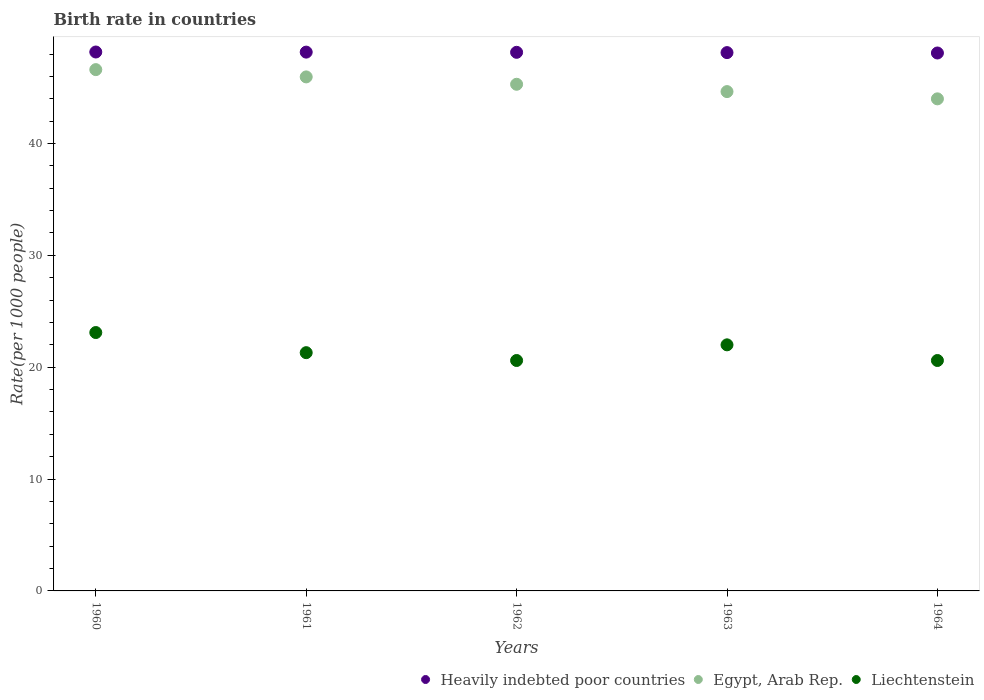What is the birth rate in Egypt, Arab Rep. in 1961?
Provide a short and direct response. 45.95. Across all years, what is the maximum birth rate in Heavily indebted poor countries?
Your response must be concise. 48.18. Across all years, what is the minimum birth rate in Egypt, Arab Rep.?
Offer a terse response. 43.99. In which year was the birth rate in Liechtenstein maximum?
Provide a succinct answer. 1960. What is the total birth rate in Heavily indebted poor countries in the graph?
Offer a very short reply. 240.72. What is the difference between the birth rate in Egypt, Arab Rep. in 1961 and that in 1962?
Provide a short and direct response. 0.66. What is the difference between the birth rate in Liechtenstein in 1962 and the birth rate in Egypt, Arab Rep. in 1963?
Offer a terse response. -24.04. What is the average birth rate in Liechtenstein per year?
Offer a terse response. 21.52. In the year 1964, what is the difference between the birth rate in Liechtenstein and birth rate in Egypt, Arab Rep.?
Give a very brief answer. -23.39. What is the ratio of the birth rate in Liechtenstein in 1961 to that in 1964?
Your response must be concise. 1.03. Is the birth rate in Egypt, Arab Rep. in 1960 less than that in 1963?
Your response must be concise. No. What is the difference between the highest and the second highest birth rate in Heavily indebted poor countries?
Offer a very short reply. 0.01. What is the difference between the highest and the lowest birth rate in Liechtenstein?
Keep it short and to the point. 2.5. In how many years, is the birth rate in Heavily indebted poor countries greater than the average birth rate in Heavily indebted poor countries taken over all years?
Your response must be concise. 3. Is the birth rate in Egypt, Arab Rep. strictly greater than the birth rate in Heavily indebted poor countries over the years?
Keep it short and to the point. No. How many dotlines are there?
Give a very brief answer. 3. How many years are there in the graph?
Provide a short and direct response. 5. Are the values on the major ticks of Y-axis written in scientific E-notation?
Provide a succinct answer. No. Does the graph contain grids?
Your answer should be compact. No. How are the legend labels stacked?
Make the answer very short. Horizontal. What is the title of the graph?
Your answer should be very brief. Birth rate in countries. What is the label or title of the Y-axis?
Your response must be concise. Rate(per 1000 people). What is the Rate(per 1000 people) in Heavily indebted poor countries in 1960?
Provide a succinct answer. 48.18. What is the Rate(per 1000 people) in Egypt, Arab Rep. in 1960?
Your answer should be very brief. 46.6. What is the Rate(per 1000 people) of Liechtenstein in 1960?
Your answer should be compact. 23.1. What is the Rate(per 1000 people) of Heavily indebted poor countries in 1961?
Your answer should be very brief. 48.17. What is the Rate(per 1000 people) of Egypt, Arab Rep. in 1961?
Your answer should be compact. 45.95. What is the Rate(per 1000 people) of Liechtenstein in 1961?
Offer a terse response. 21.3. What is the Rate(per 1000 people) of Heavily indebted poor countries in 1962?
Your answer should be very brief. 48.15. What is the Rate(per 1000 people) of Egypt, Arab Rep. in 1962?
Keep it short and to the point. 45.3. What is the Rate(per 1000 people) in Liechtenstein in 1962?
Your answer should be compact. 20.6. What is the Rate(per 1000 people) of Heavily indebted poor countries in 1963?
Give a very brief answer. 48.13. What is the Rate(per 1000 people) in Egypt, Arab Rep. in 1963?
Offer a terse response. 44.64. What is the Rate(per 1000 people) of Liechtenstein in 1963?
Your answer should be very brief. 22. What is the Rate(per 1000 people) of Heavily indebted poor countries in 1964?
Give a very brief answer. 48.09. What is the Rate(per 1000 people) in Egypt, Arab Rep. in 1964?
Your answer should be compact. 43.99. What is the Rate(per 1000 people) of Liechtenstein in 1964?
Offer a very short reply. 20.6. Across all years, what is the maximum Rate(per 1000 people) of Heavily indebted poor countries?
Offer a very short reply. 48.18. Across all years, what is the maximum Rate(per 1000 people) of Egypt, Arab Rep.?
Give a very brief answer. 46.6. Across all years, what is the maximum Rate(per 1000 people) of Liechtenstein?
Keep it short and to the point. 23.1. Across all years, what is the minimum Rate(per 1000 people) of Heavily indebted poor countries?
Give a very brief answer. 48.09. Across all years, what is the minimum Rate(per 1000 people) of Egypt, Arab Rep.?
Offer a terse response. 43.99. Across all years, what is the minimum Rate(per 1000 people) in Liechtenstein?
Ensure brevity in your answer.  20.6. What is the total Rate(per 1000 people) of Heavily indebted poor countries in the graph?
Provide a short and direct response. 240.72. What is the total Rate(per 1000 people) of Egypt, Arab Rep. in the graph?
Make the answer very short. 226.49. What is the total Rate(per 1000 people) of Liechtenstein in the graph?
Ensure brevity in your answer.  107.6. What is the difference between the Rate(per 1000 people) of Heavily indebted poor countries in 1960 and that in 1961?
Give a very brief answer. 0.01. What is the difference between the Rate(per 1000 people) of Egypt, Arab Rep. in 1960 and that in 1961?
Your response must be concise. 0.65. What is the difference between the Rate(per 1000 people) in Heavily indebted poor countries in 1960 and that in 1962?
Offer a terse response. 0.03. What is the difference between the Rate(per 1000 people) of Egypt, Arab Rep. in 1960 and that in 1962?
Ensure brevity in your answer.  1.31. What is the difference between the Rate(per 1000 people) in Liechtenstein in 1960 and that in 1962?
Offer a very short reply. 2.5. What is the difference between the Rate(per 1000 people) of Heavily indebted poor countries in 1960 and that in 1963?
Your answer should be compact. 0.05. What is the difference between the Rate(per 1000 people) of Egypt, Arab Rep. in 1960 and that in 1963?
Offer a terse response. 1.97. What is the difference between the Rate(per 1000 people) in Liechtenstein in 1960 and that in 1963?
Your response must be concise. 1.1. What is the difference between the Rate(per 1000 people) in Heavily indebted poor countries in 1960 and that in 1964?
Provide a short and direct response. 0.09. What is the difference between the Rate(per 1000 people) in Egypt, Arab Rep. in 1960 and that in 1964?
Offer a very short reply. 2.61. What is the difference between the Rate(per 1000 people) of Heavily indebted poor countries in 1961 and that in 1962?
Keep it short and to the point. 0.02. What is the difference between the Rate(per 1000 people) in Egypt, Arab Rep. in 1961 and that in 1962?
Provide a short and direct response. 0.66. What is the difference between the Rate(per 1000 people) in Heavily indebted poor countries in 1961 and that in 1963?
Keep it short and to the point. 0.04. What is the difference between the Rate(per 1000 people) of Egypt, Arab Rep. in 1961 and that in 1963?
Keep it short and to the point. 1.31. What is the difference between the Rate(per 1000 people) of Heavily indebted poor countries in 1961 and that in 1964?
Give a very brief answer. 0.08. What is the difference between the Rate(per 1000 people) of Egypt, Arab Rep. in 1961 and that in 1964?
Offer a terse response. 1.96. What is the difference between the Rate(per 1000 people) in Liechtenstein in 1961 and that in 1964?
Provide a short and direct response. 0.7. What is the difference between the Rate(per 1000 people) in Heavily indebted poor countries in 1962 and that in 1963?
Ensure brevity in your answer.  0.03. What is the difference between the Rate(per 1000 people) in Egypt, Arab Rep. in 1962 and that in 1963?
Make the answer very short. 0.66. What is the difference between the Rate(per 1000 people) in Heavily indebted poor countries in 1962 and that in 1964?
Keep it short and to the point. 0.06. What is the difference between the Rate(per 1000 people) in Egypt, Arab Rep. in 1962 and that in 1964?
Offer a terse response. 1.3. What is the difference between the Rate(per 1000 people) in Liechtenstein in 1962 and that in 1964?
Your response must be concise. 0. What is the difference between the Rate(per 1000 people) in Heavily indebted poor countries in 1963 and that in 1964?
Offer a very short reply. 0.03. What is the difference between the Rate(per 1000 people) in Egypt, Arab Rep. in 1963 and that in 1964?
Make the answer very short. 0.65. What is the difference between the Rate(per 1000 people) of Liechtenstein in 1963 and that in 1964?
Provide a succinct answer. 1.4. What is the difference between the Rate(per 1000 people) of Heavily indebted poor countries in 1960 and the Rate(per 1000 people) of Egypt, Arab Rep. in 1961?
Give a very brief answer. 2.23. What is the difference between the Rate(per 1000 people) of Heavily indebted poor countries in 1960 and the Rate(per 1000 people) of Liechtenstein in 1961?
Your answer should be very brief. 26.88. What is the difference between the Rate(per 1000 people) of Egypt, Arab Rep. in 1960 and the Rate(per 1000 people) of Liechtenstein in 1961?
Keep it short and to the point. 25.3. What is the difference between the Rate(per 1000 people) of Heavily indebted poor countries in 1960 and the Rate(per 1000 people) of Egypt, Arab Rep. in 1962?
Give a very brief answer. 2.88. What is the difference between the Rate(per 1000 people) in Heavily indebted poor countries in 1960 and the Rate(per 1000 people) in Liechtenstein in 1962?
Offer a very short reply. 27.58. What is the difference between the Rate(per 1000 people) in Egypt, Arab Rep. in 1960 and the Rate(per 1000 people) in Liechtenstein in 1962?
Provide a short and direct response. 26. What is the difference between the Rate(per 1000 people) of Heavily indebted poor countries in 1960 and the Rate(per 1000 people) of Egypt, Arab Rep. in 1963?
Provide a short and direct response. 3.54. What is the difference between the Rate(per 1000 people) in Heavily indebted poor countries in 1960 and the Rate(per 1000 people) in Liechtenstein in 1963?
Offer a very short reply. 26.18. What is the difference between the Rate(per 1000 people) in Egypt, Arab Rep. in 1960 and the Rate(per 1000 people) in Liechtenstein in 1963?
Offer a terse response. 24.61. What is the difference between the Rate(per 1000 people) of Heavily indebted poor countries in 1960 and the Rate(per 1000 people) of Egypt, Arab Rep. in 1964?
Your response must be concise. 4.19. What is the difference between the Rate(per 1000 people) of Heavily indebted poor countries in 1960 and the Rate(per 1000 people) of Liechtenstein in 1964?
Provide a short and direct response. 27.58. What is the difference between the Rate(per 1000 people) of Egypt, Arab Rep. in 1960 and the Rate(per 1000 people) of Liechtenstein in 1964?
Offer a terse response. 26. What is the difference between the Rate(per 1000 people) of Heavily indebted poor countries in 1961 and the Rate(per 1000 people) of Egypt, Arab Rep. in 1962?
Your answer should be compact. 2.87. What is the difference between the Rate(per 1000 people) in Heavily indebted poor countries in 1961 and the Rate(per 1000 people) in Liechtenstein in 1962?
Your response must be concise. 27.57. What is the difference between the Rate(per 1000 people) in Egypt, Arab Rep. in 1961 and the Rate(per 1000 people) in Liechtenstein in 1962?
Ensure brevity in your answer.  25.35. What is the difference between the Rate(per 1000 people) in Heavily indebted poor countries in 1961 and the Rate(per 1000 people) in Egypt, Arab Rep. in 1963?
Give a very brief answer. 3.53. What is the difference between the Rate(per 1000 people) in Heavily indebted poor countries in 1961 and the Rate(per 1000 people) in Liechtenstein in 1963?
Your answer should be compact. 26.17. What is the difference between the Rate(per 1000 people) of Egypt, Arab Rep. in 1961 and the Rate(per 1000 people) of Liechtenstein in 1963?
Offer a very short reply. 23.95. What is the difference between the Rate(per 1000 people) of Heavily indebted poor countries in 1961 and the Rate(per 1000 people) of Egypt, Arab Rep. in 1964?
Your answer should be very brief. 4.18. What is the difference between the Rate(per 1000 people) in Heavily indebted poor countries in 1961 and the Rate(per 1000 people) in Liechtenstein in 1964?
Offer a very short reply. 27.57. What is the difference between the Rate(per 1000 people) in Egypt, Arab Rep. in 1961 and the Rate(per 1000 people) in Liechtenstein in 1964?
Provide a short and direct response. 25.35. What is the difference between the Rate(per 1000 people) of Heavily indebted poor countries in 1962 and the Rate(per 1000 people) of Egypt, Arab Rep. in 1963?
Make the answer very short. 3.51. What is the difference between the Rate(per 1000 people) of Heavily indebted poor countries in 1962 and the Rate(per 1000 people) of Liechtenstein in 1963?
Your answer should be very brief. 26.15. What is the difference between the Rate(per 1000 people) in Egypt, Arab Rep. in 1962 and the Rate(per 1000 people) in Liechtenstein in 1963?
Offer a very short reply. 23.3. What is the difference between the Rate(per 1000 people) of Heavily indebted poor countries in 1962 and the Rate(per 1000 people) of Egypt, Arab Rep. in 1964?
Offer a very short reply. 4.16. What is the difference between the Rate(per 1000 people) in Heavily indebted poor countries in 1962 and the Rate(per 1000 people) in Liechtenstein in 1964?
Your answer should be compact. 27.55. What is the difference between the Rate(per 1000 people) in Egypt, Arab Rep. in 1962 and the Rate(per 1000 people) in Liechtenstein in 1964?
Offer a terse response. 24.7. What is the difference between the Rate(per 1000 people) in Heavily indebted poor countries in 1963 and the Rate(per 1000 people) in Egypt, Arab Rep. in 1964?
Your answer should be very brief. 4.13. What is the difference between the Rate(per 1000 people) in Heavily indebted poor countries in 1963 and the Rate(per 1000 people) in Liechtenstein in 1964?
Provide a succinct answer. 27.53. What is the difference between the Rate(per 1000 people) in Egypt, Arab Rep. in 1963 and the Rate(per 1000 people) in Liechtenstein in 1964?
Offer a very short reply. 24.04. What is the average Rate(per 1000 people) of Heavily indebted poor countries per year?
Provide a succinct answer. 48.14. What is the average Rate(per 1000 people) of Egypt, Arab Rep. per year?
Provide a short and direct response. 45.3. What is the average Rate(per 1000 people) of Liechtenstein per year?
Your answer should be very brief. 21.52. In the year 1960, what is the difference between the Rate(per 1000 people) of Heavily indebted poor countries and Rate(per 1000 people) of Egypt, Arab Rep.?
Provide a succinct answer. 1.58. In the year 1960, what is the difference between the Rate(per 1000 people) in Heavily indebted poor countries and Rate(per 1000 people) in Liechtenstein?
Make the answer very short. 25.08. In the year 1960, what is the difference between the Rate(per 1000 people) in Egypt, Arab Rep. and Rate(per 1000 people) in Liechtenstein?
Ensure brevity in your answer.  23.5. In the year 1961, what is the difference between the Rate(per 1000 people) of Heavily indebted poor countries and Rate(per 1000 people) of Egypt, Arab Rep.?
Offer a terse response. 2.22. In the year 1961, what is the difference between the Rate(per 1000 people) of Heavily indebted poor countries and Rate(per 1000 people) of Liechtenstein?
Provide a short and direct response. 26.87. In the year 1961, what is the difference between the Rate(per 1000 people) in Egypt, Arab Rep. and Rate(per 1000 people) in Liechtenstein?
Offer a terse response. 24.65. In the year 1962, what is the difference between the Rate(per 1000 people) of Heavily indebted poor countries and Rate(per 1000 people) of Egypt, Arab Rep.?
Give a very brief answer. 2.86. In the year 1962, what is the difference between the Rate(per 1000 people) of Heavily indebted poor countries and Rate(per 1000 people) of Liechtenstein?
Offer a terse response. 27.55. In the year 1962, what is the difference between the Rate(per 1000 people) of Egypt, Arab Rep. and Rate(per 1000 people) of Liechtenstein?
Provide a succinct answer. 24.7. In the year 1963, what is the difference between the Rate(per 1000 people) in Heavily indebted poor countries and Rate(per 1000 people) in Egypt, Arab Rep.?
Ensure brevity in your answer.  3.49. In the year 1963, what is the difference between the Rate(per 1000 people) in Heavily indebted poor countries and Rate(per 1000 people) in Liechtenstein?
Keep it short and to the point. 26.13. In the year 1963, what is the difference between the Rate(per 1000 people) of Egypt, Arab Rep. and Rate(per 1000 people) of Liechtenstein?
Your answer should be very brief. 22.64. In the year 1964, what is the difference between the Rate(per 1000 people) of Heavily indebted poor countries and Rate(per 1000 people) of Egypt, Arab Rep.?
Offer a very short reply. 4.1. In the year 1964, what is the difference between the Rate(per 1000 people) of Heavily indebted poor countries and Rate(per 1000 people) of Liechtenstein?
Provide a succinct answer. 27.49. In the year 1964, what is the difference between the Rate(per 1000 people) of Egypt, Arab Rep. and Rate(per 1000 people) of Liechtenstein?
Give a very brief answer. 23.39. What is the ratio of the Rate(per 1000 people) of Heavily indebted poor countries in 1960 to that in 1961?
Offer a terse response. 1. What is the ratio of the Rate(per 1000 people) in Egypt, Arab Rep. in 1960 to that in 1961?
Your response must be concise. 1.01. What is the ratio of the Rate(per 1000 people) of Liechtenstein in 1960 to that in 1961?
Your response must be concise. 1.08. What is the ratio of the Rate(per 1000 people) in Egypt, Arab Rep. in 1960 to that in 1962?
Your answer should be compact. 1.03. What is the ratio of the Rate(per 1000 people) in Liechtenstein in 1960 to that in 1962?
Keep it short and to the point. 1.12. What is the ratio of the Rate(per 1000 people) in Egypt, Arab Rep. in 1960 to that in 1963?
Your answer should be compact. 1.04. What is the ratio of the Rate(per 1000 people) in Liechtenstein in 1960 to that in 1963?
Offer a very short reply. 1.05. What is the ratio of the Rate(per 1000 people) of Heavily indebted poor countries in 1960 to that in 1964?
Your response must be concise. 1. What is the ratio of the Rate(per 1000 people) of Egypt, Arab Rep. in 1960 to that in 1964?
Offer a very short reply. 1.06. What is the ratio of the Rate(per 1000 people) in Liechtenstein in 1960 to that in 1964?
Give a very brief answer. 1.12. What is the ratio of the Rate(per 1000 people) in Egypt, Arab Rep. in 1961 to that in 1962?
Your response must be concise. 1.01. What is the ratio of the Rate(per 1000 people) of Liechtenstein in 1961 to that in 1962?
Offer a terse response. 1.03. What is the ratio of the Rate(per 1000 people) in Heavily indebted poor countries in 1961 to that in 1963?
Your answer should be very brief. 1. What is the ratio of the Rate(per 1000 people) of Egypt, Arab Rep. in 1961 to that in 1963?
Make the answer very short. 1.03. What is the ratio of the Rate(per 1000 people) in Liechtenstein in 1961 to that in 1963?
Make the answer very short. 0.97. What is the ratio of the Rate(per 1000 people) in Egypt, Arab Rep. in 1961 to that in 1964?
Offer a terse response. 1.04. What is the ratio of the Rate(per 1000 people) of Liechtenstein in 1961 to that in 1964?
Provide a short and direct response. 1.03. What is the ratio of the Rate(per 1000 people) in Heavily indebted poor countries in 1962 to that in 1963?
Keep it short and to the point. 1. What is the ratio of the Rate(per 1000 people) in Egypt, Arab Rep. in 1962 to that in 1963?
Keep it short and to the point. 1.01. What is the ratio of the Rate(per 1000 people) of Liechtenstein in 1962 to that in 1963?
Your response must be concise. 0.94. What is the ratio of the Rate(per 1000 people) in Heavily indebted poor countries in 1962 to that in 1964?
Keep it short and to the point. 1. What is the ratio of the Rate(per 1000 people) in Egypt, Arab Rep. in 1962 to that in 1964?
Make the answer very short. 1.03. What is the ratio of the Rate(per 1000 people) in Heavily indebted poor countries in 1963 to that in 1964?
Provide a succinct answer. 1. What is the ratio of the Rate(per 1000 people) in Egypt, Arab Rep. in 1963 to that in 1964?
Make the answer very short. 1.01. What is the ratio of the Rate(per 1000 people) in Liechtenstein in 1963 to that in 1964?
Offer a terse response. 1.07. What is the difference between the highest and the second highest Rate(per 1000 people) in Heavily indebted poor countries?
Provide a short and direct response. 0.01. What is the difference between the highest and the second highest Rate(per 1000 people) of Egypt, Arab Rep.?
Provide a short and direct response. 0.65. What is the difference between the highest and the lowest Rate(per 1000 people) in Heavily indebted poor countries?
Your answer should be compact. 0.09. What is the difference between the highest and the lowest Rate(per 1000 people) in Egypt, Arab Rep.?
Your response must be concise. 2.61. What is the difference between the highest and the lowest Rate(per 1000 people) of Liechtenstein?
Ensure brevity in your answer.  2.5. 